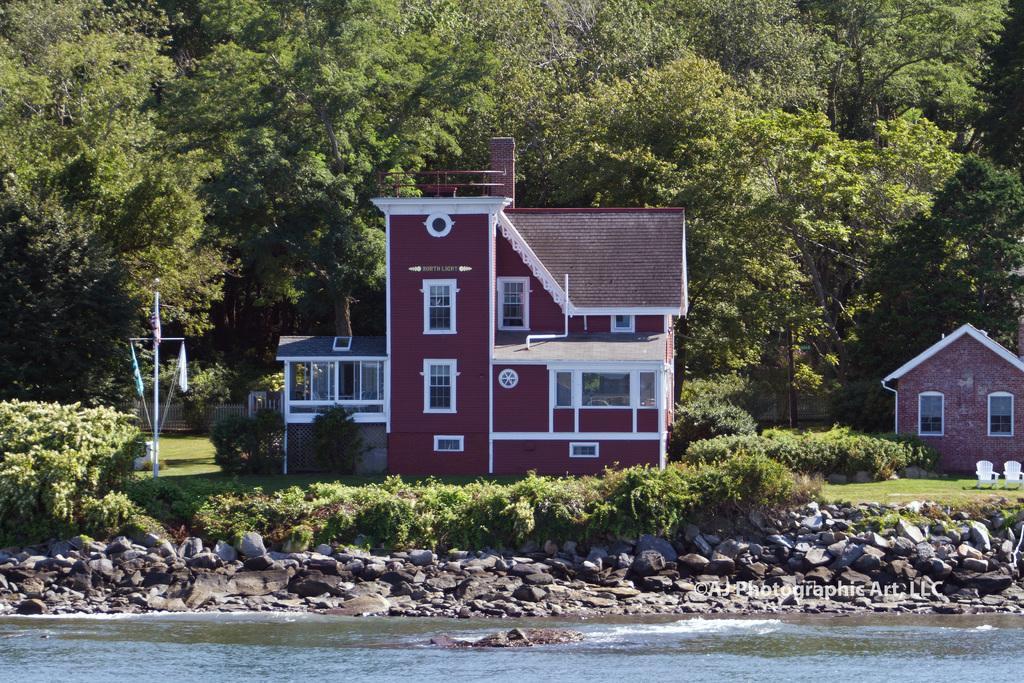Please provide a concise description of this image. In this image I can see building in maroon color, at right I can see the other building. At the background I can see trees in green color, in front there are few stones and water. 